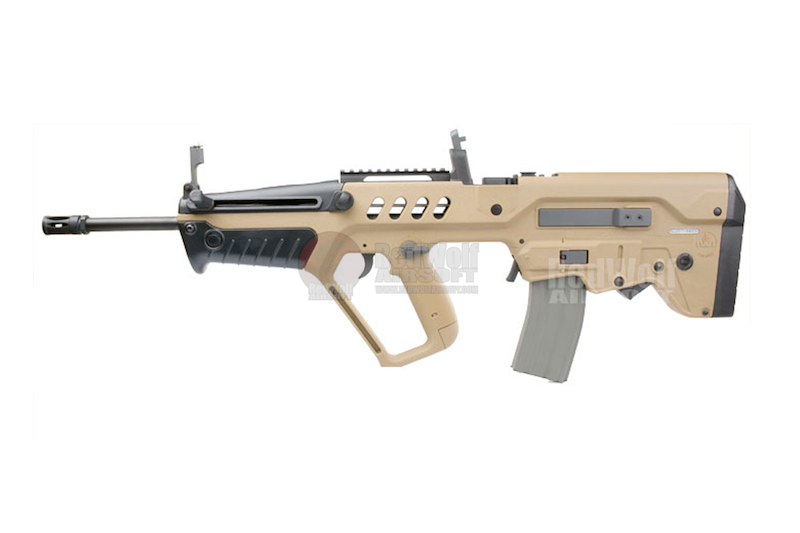What specific features of this firearm suggest it is designed for precision shooting? The firearm has several features indicating it is designed for precision shooting. The integrated iron sights on the carrying handle enable quick target acquisition. The Picatinny rail system allows for the attachment of advanced optics, which significantly improves shooting accuracy at various ranges. The firearm’s bullpup design increases accuracy by enabling a longer barrel within a shorter overall weapon length, which enhances bullet velocity and stability. Additionally, the ergonomic design provides better grip and control, further aiding in precision. 